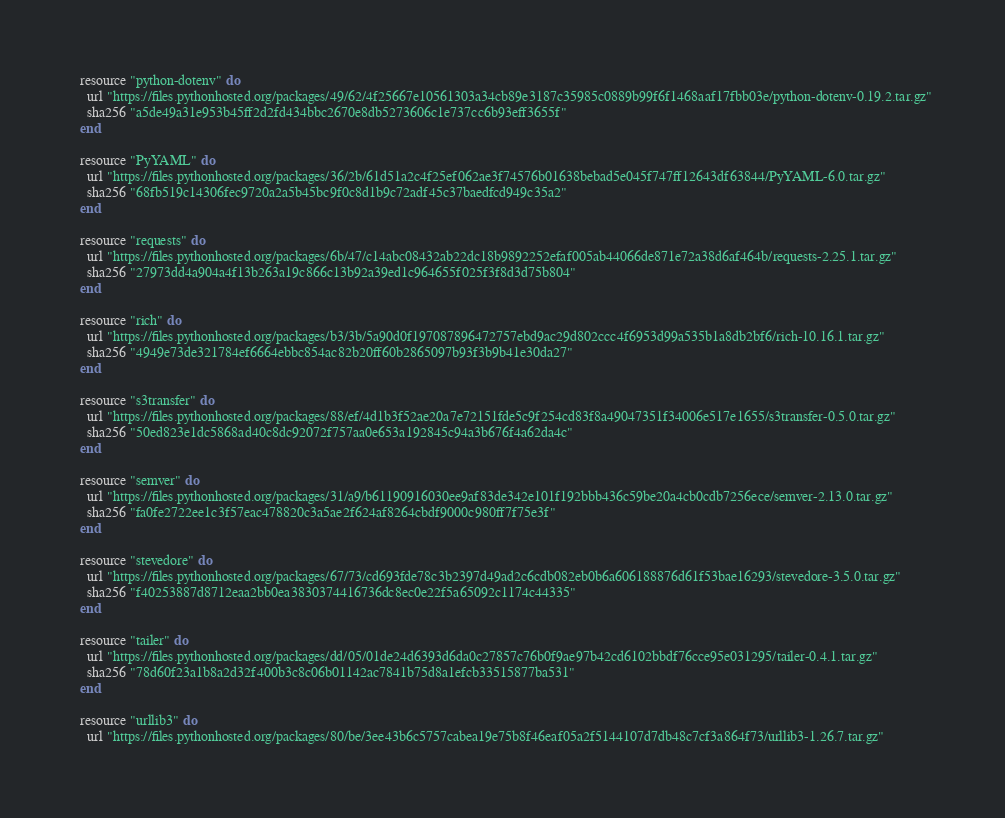Convert code to text. <code><loc_0><loc_0><loc_500><loc_500><_Ruby_>
  resource "python-dotenv" do
    url "https://files.pythonhosted.org/packages/49/62/4f25667e10561303a34cb89e3187c35985c0889b99f6f1468aaf17fbb03e/python-dotenv-0.19.2.tar.gz"
    sha256 "a5de49a31e953b45ff2d2fd434bbc2670e8db5273606c1e737cc6b93eff3655f"
  end

  resource "PyYAML" do
    url "https://files.pythonhosted.org/packages/36/2b/61d51a2c4f25ef062ae3f74576b01638bebad5e045f747ff12643df63844/PyYAML-6.0.tar.gz"
    sha256 "68fb519c14306fec9720a2a5b45bc9f0c8d1b9c72adf45c37baedfcd949c35a2"
  end

  resource "requests" do
    url "https://files.pythonhosted.org/packages/6b/47/c14abc08432ab22dc18b9892252efaf005ab44066de871e72a38d6af464b/requests-2.25.1.tar.gz"
    sha256 "27973dd4a904a4f13b263a19c866c13b92a39ed1c964655f025f3f8d3d75b804"
  end

  resource "rich" do
    url "https://files.pythonhosted.org/packages/b3/3b/5a90d0f197087896472757ebd9ac29d802ccc4f6953d99a535b1a8db2bf6/rich-10.16.1.tar.gz"
    sha256 "4949e73de321784ef6664ebbc854ac82b20ff60b2865097b93f3b9b41e30da27"
  end

  resource "s3transfer" do
    url "https://files.pythonhosted.org/packages/88/ef/4d1b3f52ae20a7e72151fde5c9f254cd83f8a49047351f34006e517e1655/s3transfer-0.5.0.tar.gz"
    sha256 "50ed823e1dc5868ad40c8dc92072f757aa0e653a192845c94a3b676f4a62da4c"
  end

  resource "semver" do
    url "https://files.pythonhosted.org/packages/31/a9/b61190916030ee9af83de342e101f192bbb436c59be20a4cb0cdb7256ece/semver-2.13.0.tar.gz"
    sha256 "fa0fe2722ee1c3f57eac478820c3a5ae2f624af8264cbdf9000c980ff7f75e3f"
  end

  resource "stevedore" do
    url "https://files.pythonhosted.org/packages/67/73/cd693fde78c3b2397d49ad2c6cdb082eb0b6a606188876d61f53bae16293/stevedore-3.5.0.tar.gz"
    sha256 "f40253887d8712eaa2bb0ea3830374416736dc8ec0e22f5a65092c1174c44335"
  end

  resource "tailer" do
    url "https://files.pythonhosted.org/packages/dd/05/01de24d6393d6da0c27857c76b0f9ae97b42cd6102bbdf76cce95e031295/tailer-0.4.1.tar.gz"
    sha256 "78d60f23a1b8a2d32f400b3c8c06b01142ac7841b75d8a1efcb33515877ba531"
  end

  resource "urllib3" do
    url "https://files.pythonhosted.org/packages/80/be/3ee43b6c5757cabea19e75b8f46eaf05a2f5144107d7db48c7cf3a864f73/urllib3-1.26.7.tar.gz"</code> 